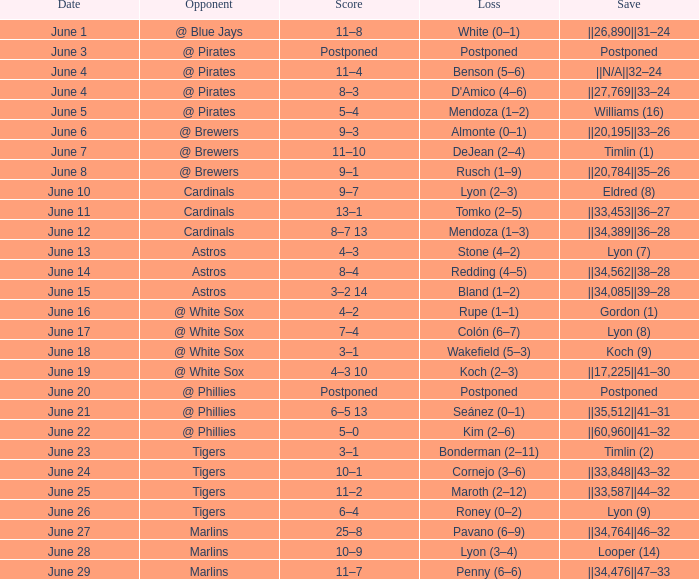Who is the opponent with a score of 6–5 13? @ Phillies. Parse the full table. {'header': ['Date', 'Opponent', 'Score', 'Loss', 'Save'], 'rows': [['June 1', '@ Blue Jays', '11–8', 'White (0–1)', '||26,890||31–24'], ['June 3', '@ Pirates', 'Postponed', 'Postponed', 'Postponed'], ['June 4', '@ Pirates', '11–4', 'Benson (5–6)', '||N/A||32–24'], ['June 4', '@ Pirates', '8–3', "D'Amico (4–6)", '||27,769||33–24'], ['June 5', '@ Pirates', '5–4', 'Mendoza (1–2)', 'Williams (16)'], ['June 6', '@ Brewers', '9–3', 'Almonte (0–1)', '||20,195||33–26'], ['June 7', '@ Brewers', '11–10', 'DeJean (2–4)', 'Timlin (1)'], ['June 8', '@ Brewers', '9–1', 'Rusch (1–9)', '||20,784||35–26'], ['June 10', 'Cardinals', '9–7', 'Lyon (2–3)', 'Eldred (8)'], ['June 11', 'Cardinals', '13–1', 'Tomko (2–5)', '||33,453||36–27'], ['June 12', 'Cardinals', '8–7 13', 'Mendoza (1–3)', '||34,389||36–28'], ['June 13', 'Astros', '4–3', 'Stone (4–2)', 'Lyon (7)'], ['June 14', 'Astros', '8–4', 'Redding (4–5)', '||34,562||38–28'], ['June 15', 'Astros', '3–2 14', 'Bland (1–2)', '||34,085||39–28'], ['June 16', '@ White Sox', '4–2', 'Rupe (1–1)', 'Gordon (1)'], ['June 17', '@ White Sox', '7–4', 'Colón (6–7)', 'Lyon (8)'], ['June 18', '@ White Sox', '3–1', 'Wakefield (5–3)', 'Koch (9)'], ['June 19', '@ White Sox', '4–3 10', 'Koch (2–3)', '||17,225||41–30'], ['June 20', '@ Phillies', 'Postponed', 'Postponed', 'Postponed'], ['June 21', '@ Phillies', '6–5 13', 'Seánez (0–1)', '||35,512||41–31'], ['June 22', '@ Phillies', '5–0', 'Kim (2–6)', '||60,960||41–32'], ['June 23', 'Tigers', '3–1', 'Bonderman (2–11)', 'Timlin (2)'], ['June 24', 'Tigers', '10–1', 'Cornejo (3–6)', '||33,848||43–32'], ['June 25', 'Tigers', '11–2', 'Maroth (2–12)', '||33,587||44–32'], ['June 26', 'Tigers', '6–4', 'Roney (0–2)', 'Lyon (9)'], ['June 27', 'Marlins', '25–8', 'Pavano (6–9)', '||34,764||46–32'], ['June 28', 'Marlins', '10–9', 'Lyon (3–4)', 'Looper (14)'], ['June 29', 'Marlins', '11–7', 'Penny (6–6)', '||34,476||47–33']]} 